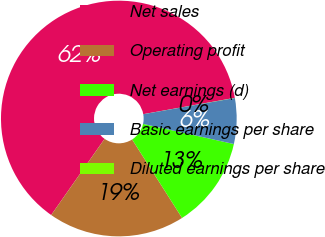<chart> <loc_0><loc_0><loc_500><loc_500><pie_chart><fcel>Net sales<fcel>Operating profit<fcel>Net earnings (d)<fcel>Basic earnings per share<fcel>Diluted earnings per share<nl><fcel>62.47%<fcel>18.75%<fcel>12.51%<fcel>6.26%<fcel>0.02%<nl></chart> 